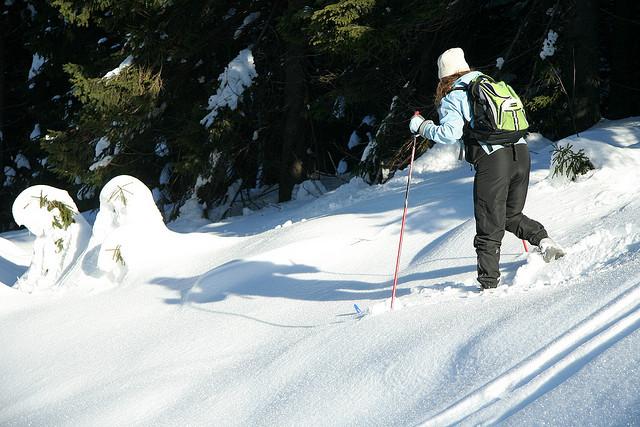What color are the Trees?
Concise answer only. Green. What is covering the ground?
Write a very short answer. Snow. What activity is this person engaging in?
Short answer required. Skiing. 